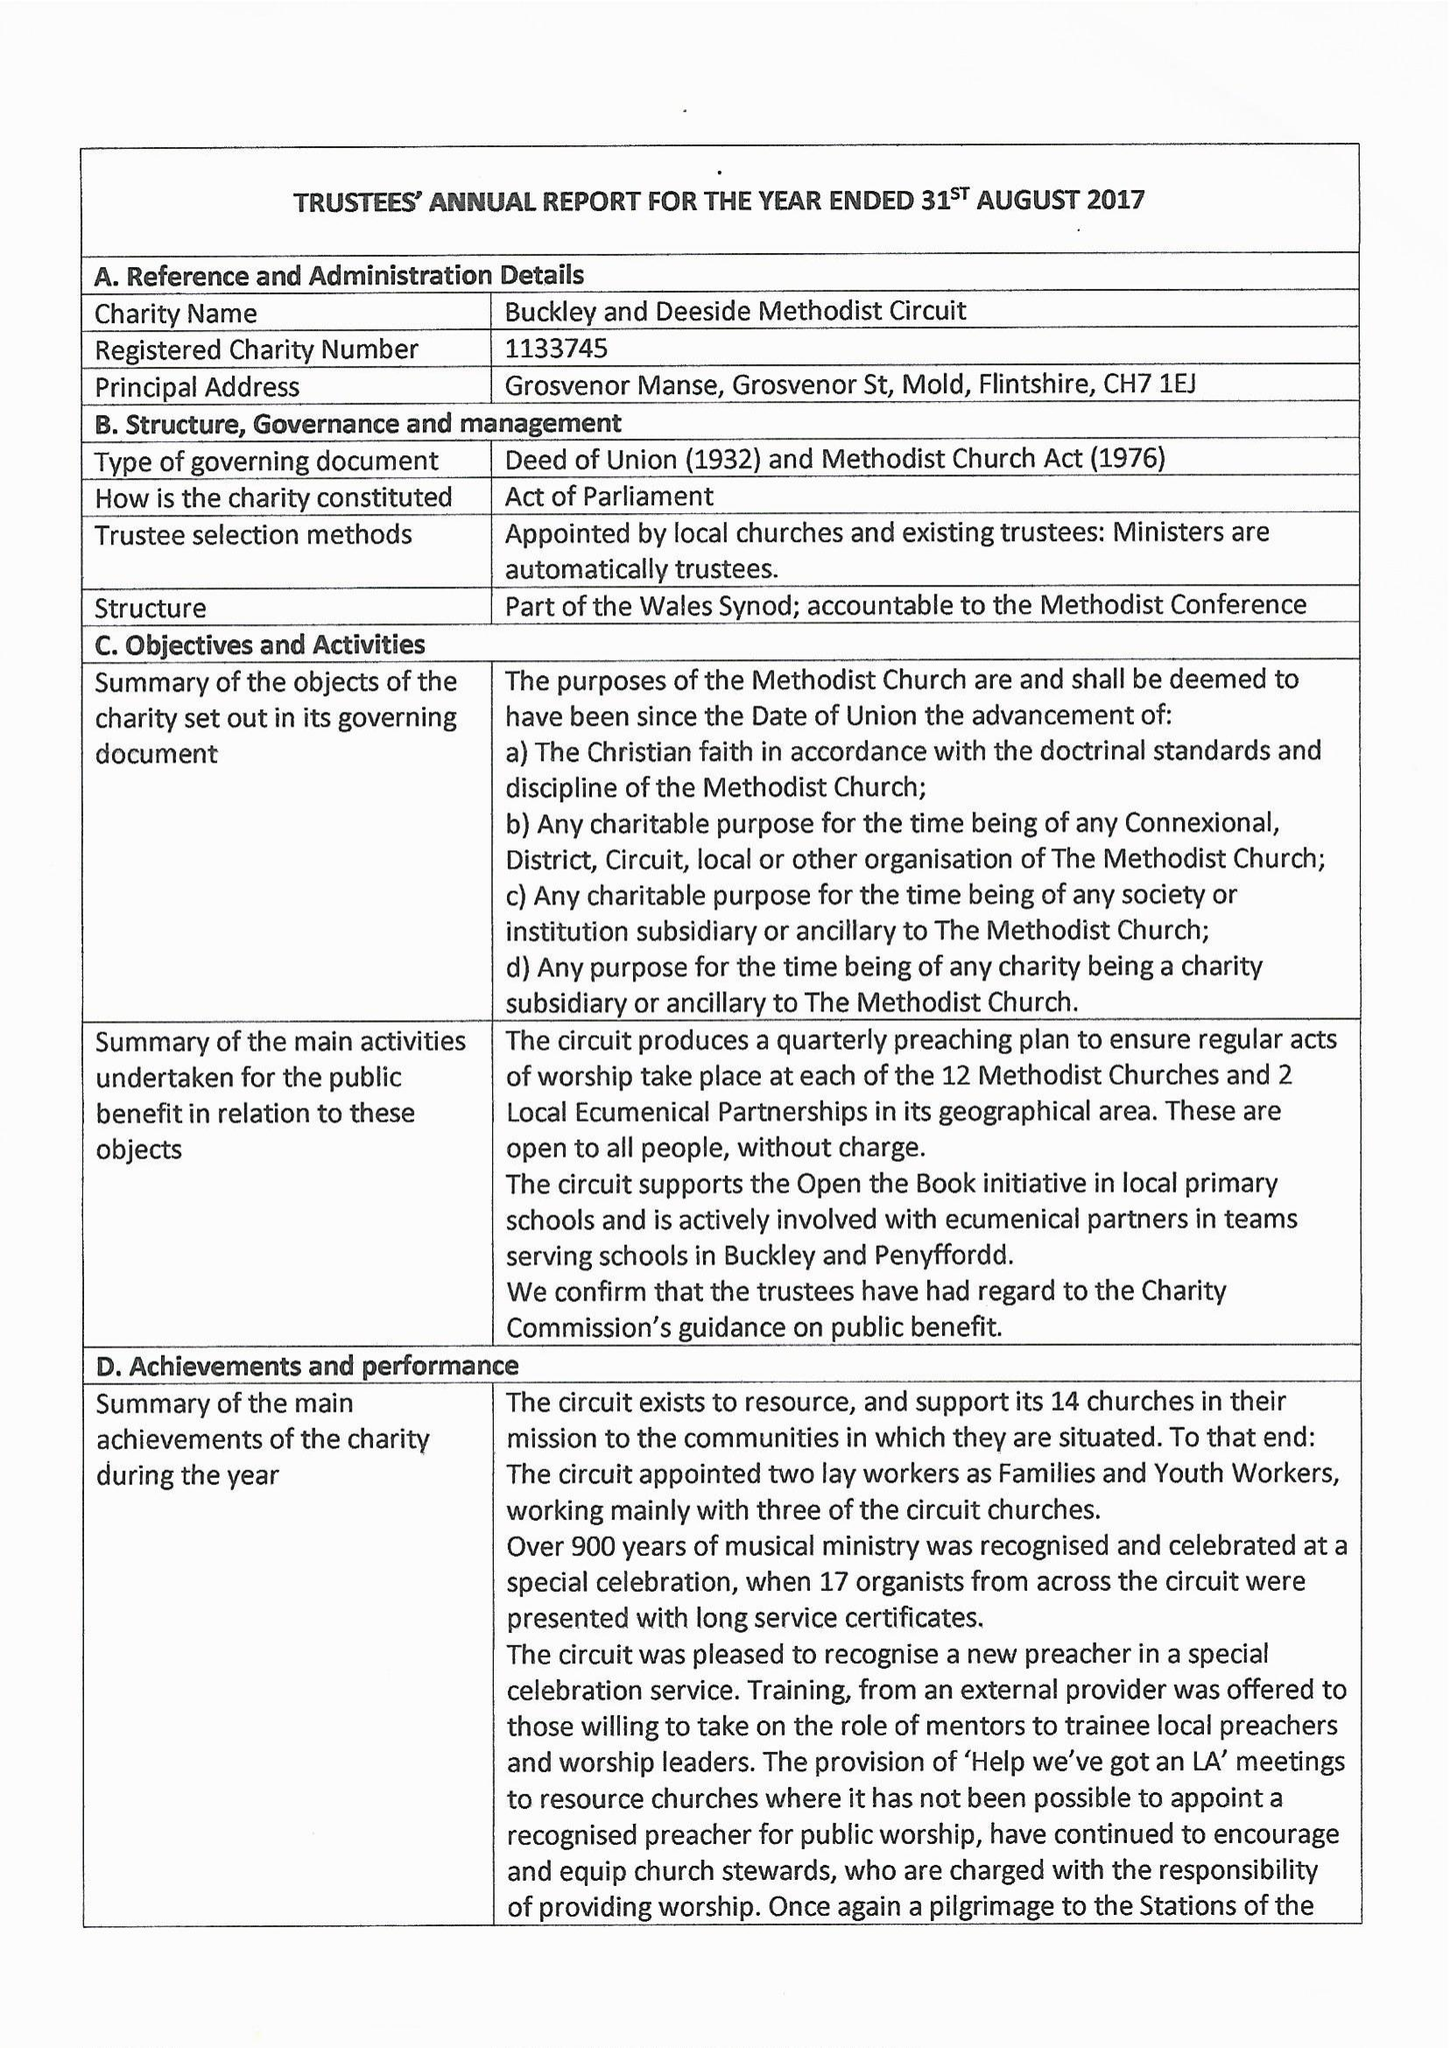What is the value for the address__post_town?
Answer the question using a single word or phrase. MOLD 